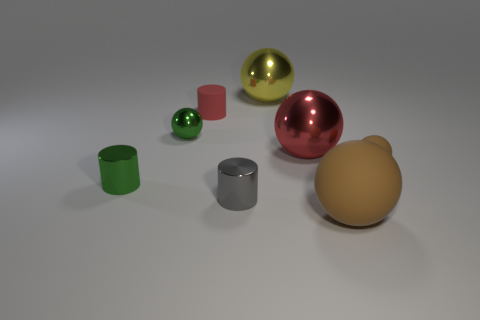Is there a big sphere that has the same color as the tiny rubber sphere?
Give a very brief answer. Yes. What number of metallic things are small things or big brown cylinders?
Provide a short and direct response. 3. Are there any tiny spheres that have the same material as the yellow thing?
Your answer should be very brief. Yes. What number of metallic things are to the left of the yellow metal ball and behind the red shiny ball?
Ensure brevity in your answer.  1. Are there fewer tiny red matte things that are in front of the tiny red rubber cylinder than big shiny spheres to the left of the red shiny ball?
Provide a succinct answer. Yes. Is the shape of the small gray object the same as the large brown object?
Your answer should be compact. No. What number of other objects are the same size as the gray object?
Your response must be concise. 4. How many things are either things to the right of the big brown matte thing or small cylinders that are to the right of the tiny green cylinder?
Your answer should be very brief. 3. How many other metal objects are the same shape as the big brown thing?
Provide a short and direct response. 3. What is the material of the small thing that is on the left side of the big brown ball and right of the matte cylinder?
Your answer should be very brief. Metal. 